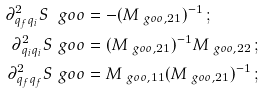Convert formula to latex. <formula><loc_0><loc_0><loc_500><loc_500>\partial ^ { 2 } _ { q _ { f } q _ { i } } S _ { \ } g o o & = - ( M _ { \ g o o , 2 1 } ) ^ { - 1 } \, ; \\ \partial ^ { 2 } _ { q _ { i } q _ { i } } S _ { \ } g o o & = ( M _ { \ g o o , 2 1 } ) ^ { - 1 } M _ { \ g o o , 2 2 } \, ; \\ \partial ^ { 2 } _ { q _ { f } q _ { f } } S _ { \ } g o o & = M _ { \ g o o , 1 1 } ( M _ { \ g o o , 2 1 } ) ^ { - 1 } \, ;</formula> 